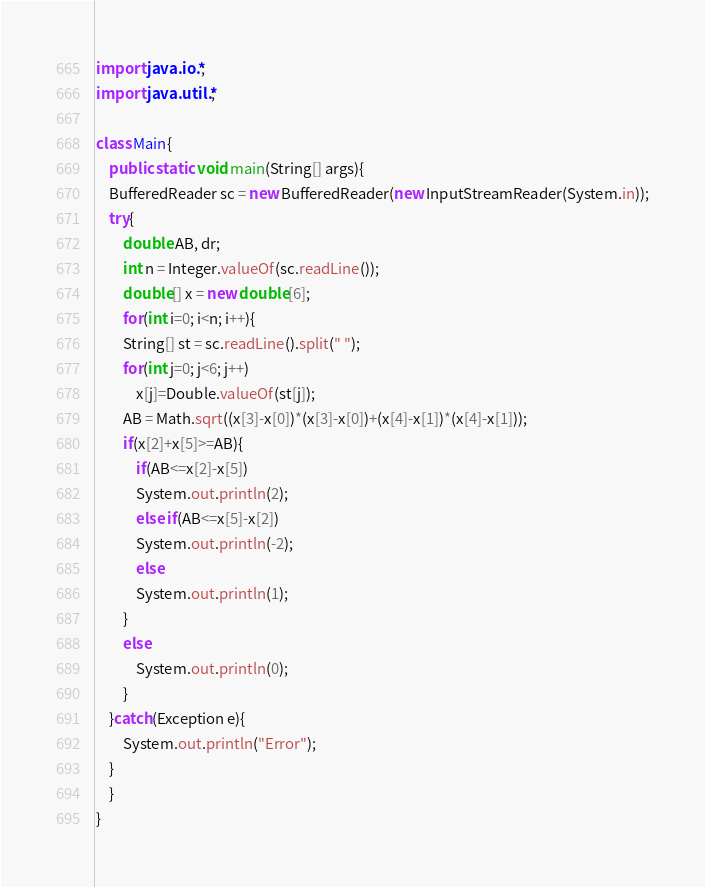<code> <loc_0><loc_0><loc_500><loc_500><_Java_>import java.io.*;
import java.util.*;

class Main{
    public static void main(String[] args){
	BufferedReader sc = new BufferedReader(new InputStreamReader(System.in));
	try{
	    double AB, dr;
	    int n = Integer.valueOf(sc.readLine());
	    double[] x = new double[6];
	    for(int i=0; i<n; i++){
		String[] st = sc.readLine().split(" ");
		for(int j=0; j<6; j++)
		    x[j]=Double.valueOf(st[j]);
		AB = Math.sqrt((x[3]-x[0])*(x[3]-x[0])+(x[4]-x[1])*(x[4]-x[1]));
		if(x[2]+x[5]>=AB){
		    if(AB<=x[2]-x[5])
			System.out.println(2);
		    else if(AB<=x[5]-x[2])
			System.out.println(-2);
		    else
			System.out.println(1);
		}
		else
		    System.out.println(0);
	    }
	}catch(Exception e){
	    System.out.println("Error");
	}
    }
}</code> 